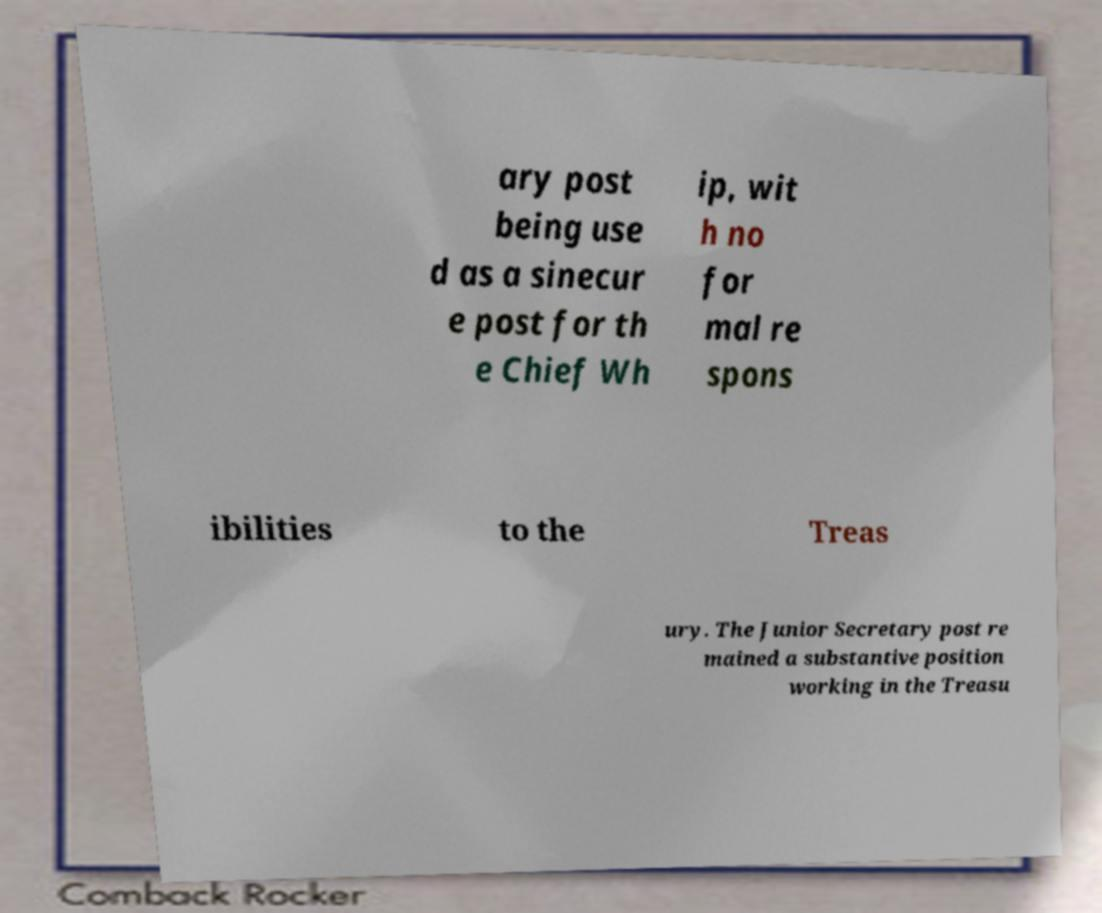There's text embedded in this image that I need extracted. Can you transcribe it verbatim? ary post being use d as a sinecur e post for th e Chief Wh ip, wit h no for mal re spons ibilities to the Treas ury. The Junior Secretary post re mained a substantive position working in the Treasu 